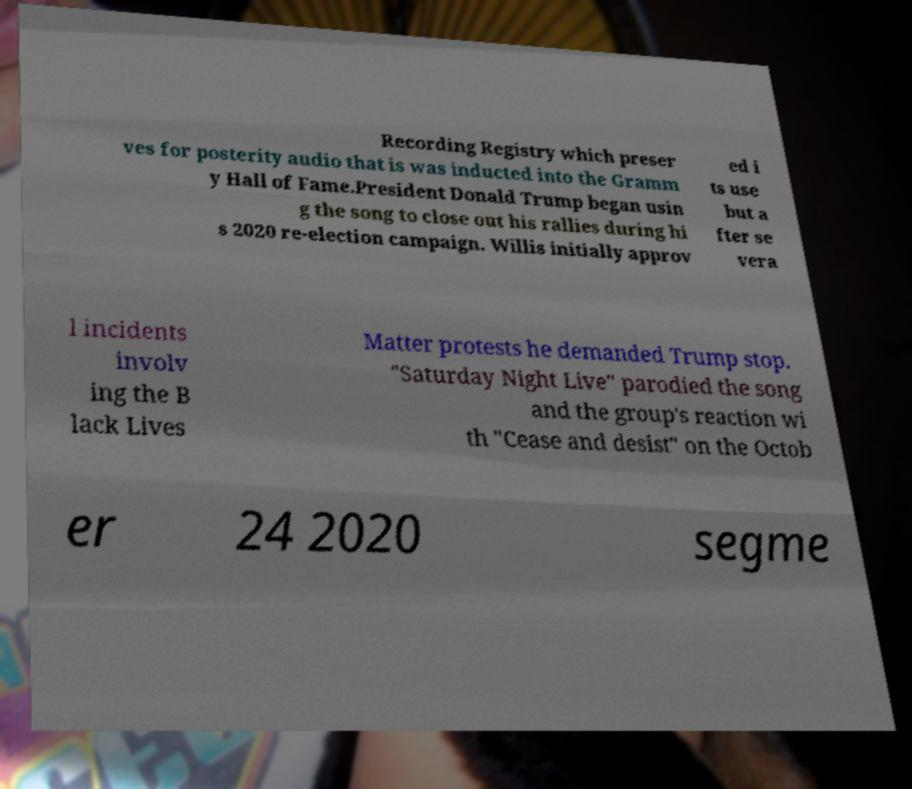Could you extract and type out the text from this image? Recording Registry which preser ves for posterity audio that is was inducted into the Gramm y Hall of Fame.President Donald Trump began usin g the song to close out his rallies during hi s 2020 re-election campaign. Willis initially approv ed i ts use but a fter se vera l incidents involv ing the B lack Lives Matter protests he demanded Trump stop. "Saturday Night Live" parodied the song and the group's reaction wi th "Cease and desist" on the Octob er 24 2020 segme 